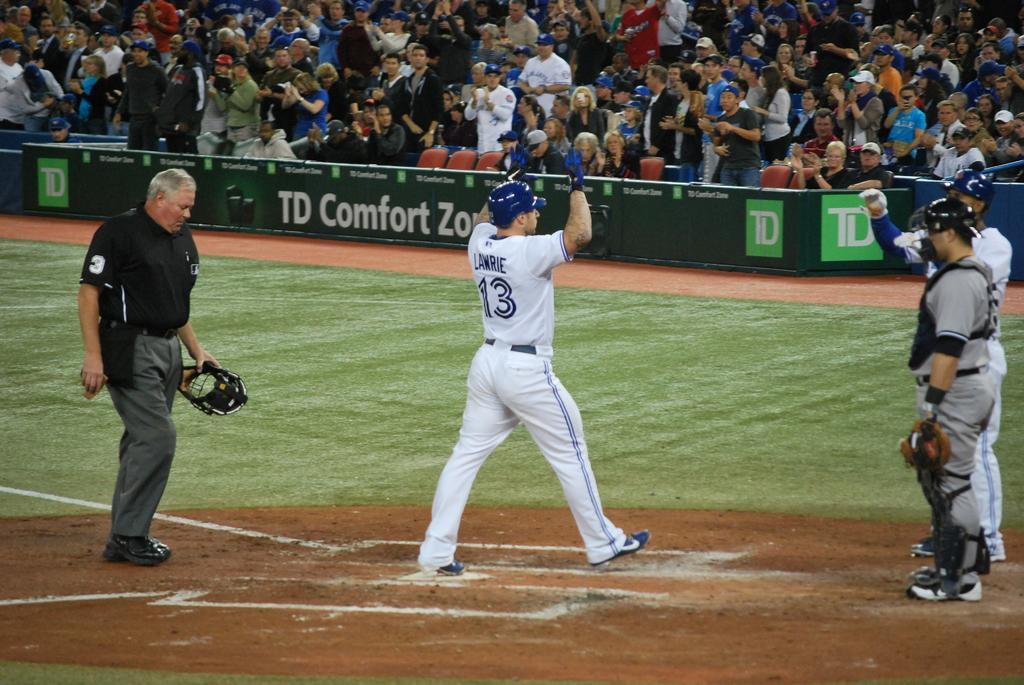<image>
Create a compact narrative representing the image presented. Lawrie crosses the plate in front of the TD Comfort Zone. 